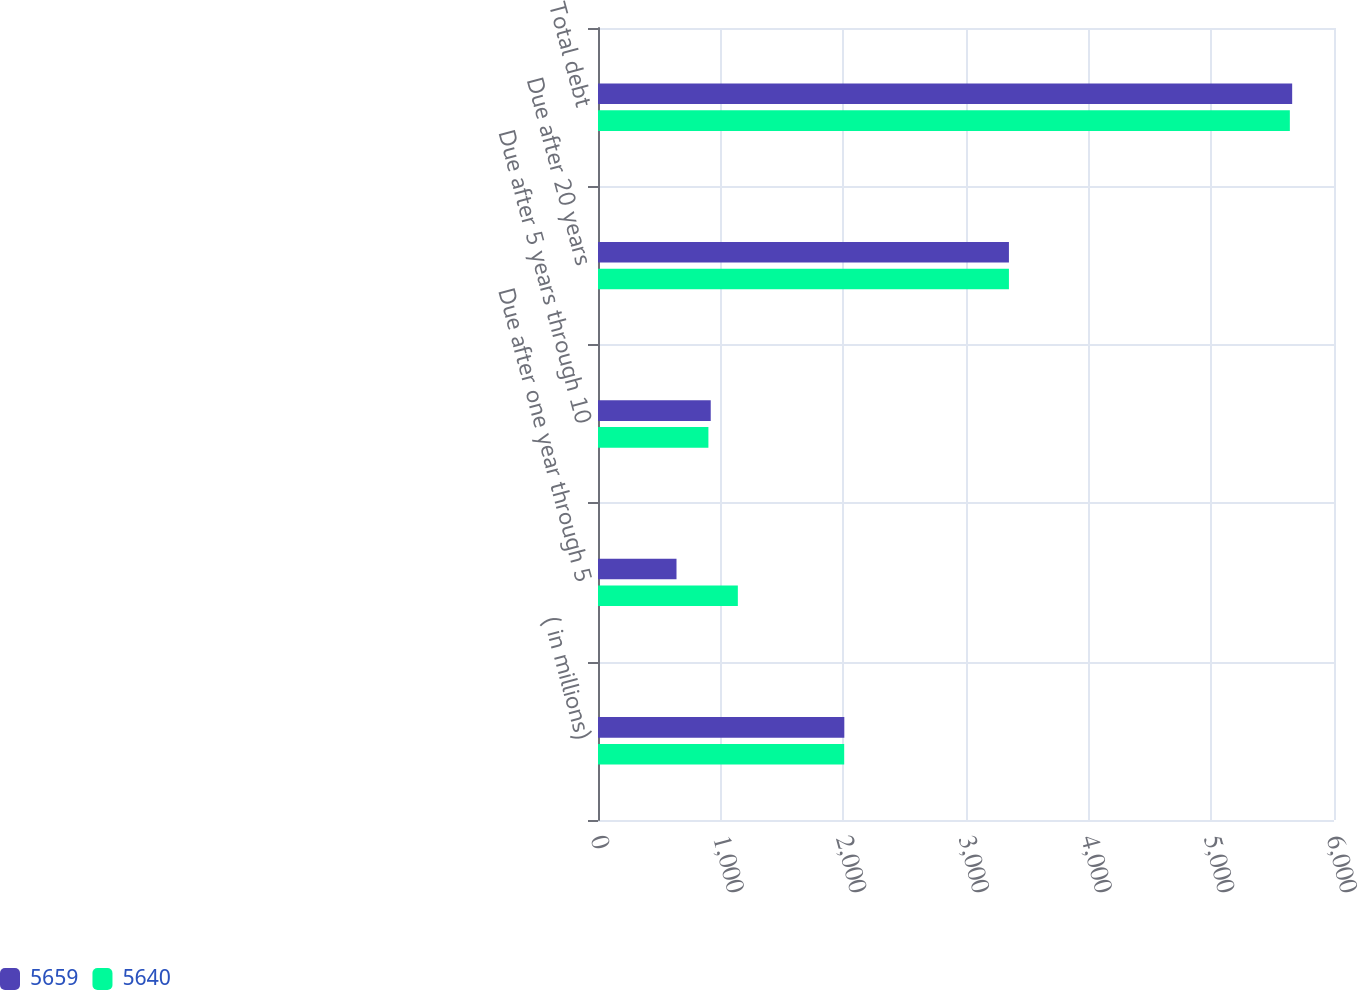Convert chart. <chart><loc_0><loc_0><loc_500><loc_500><stacked_bar_chart><ecel><fcel>( in millions)<fcel>Due after one year through 5<fcel>Due after 5 years through 10<fcel>Due after 20 years<fcel>Total debt<nl><fcel>5659<fcel>2008<fcel>640<fcel>919<fcel>3350<fcel>5659<nl><fcel>5640<fcel>2007<fcel>1140<fcel>900<fcel>3350<fcel>5640<nl></chart> 